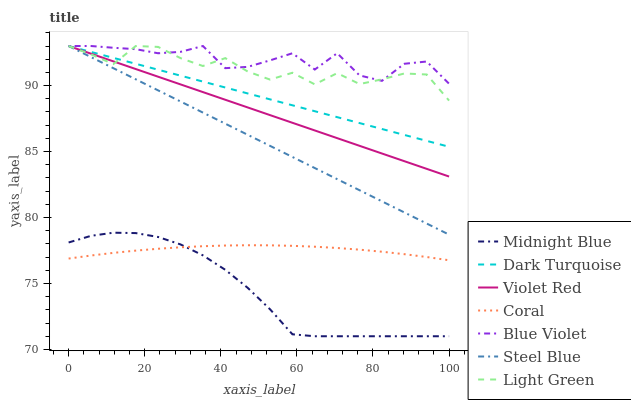Does Midnight Blue have the minimum area under the curve?
Answer yes or no. Yes. Does Blue Violet have the maximum area under the curve?
Answer yes or no. Yes. Does Dark Turquoise have the minimum area under the curve?
Answer yes or no. No. Does Dark Turquoise have the maximum area under the curve?
Answer yes or no. No. Is Dark Turquoise the smoothest?
Answer yes or no. Yes. Is Blue Violet the roughest?
Answer yes or no. Yes. Is Midnight Blue the smoothest?
Answer yes or no. No. Is Midnight Blue the roughest?
Answer yes or no. No. Does Midnight Blue have the lowest value?
Answer yes or no. Yes. Does Dark Turquoise have the lowest value?
Answer yes or no. No. Does Blue Violet have the highest value?
Answer yes or no. Yes. Does Midnight Blue have the highest value?
Answer yes or no. No. Is Coral less than Violet Red?
Answer yes or no. Yes. Is Violet Red greater than Coral?
Answer yes or no. Yes. Does Dark Turquoise intersect Blue Violet?
Answer yes or no. Yes. Is Dark Turquoise less than Blue Violet?
Answer yes or no. No. Is Dark Turquoise greater than Blue Violet?
Answer yes or no. No. Does Coral intersect Violet Red?
Answer yes or no. No. 